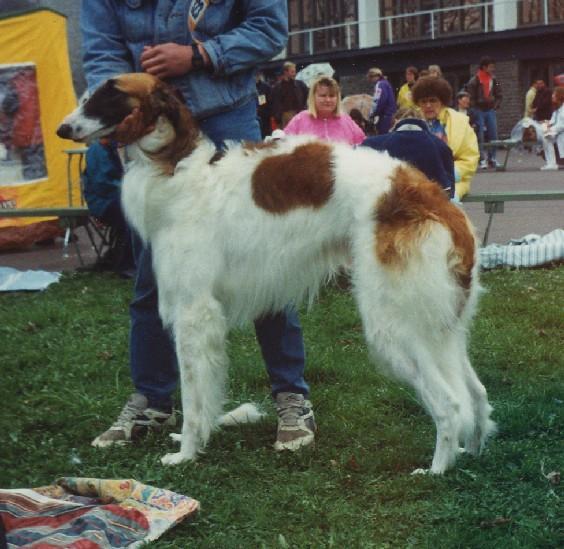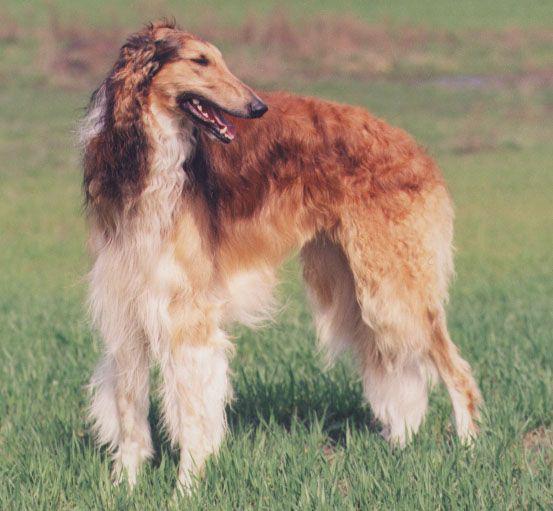The first image is the image on the left, the second image is the image on the right. Considering the images on both sides, is "All dogs are orange-and-white hounds standing with their bodies turned to the left, but one dog is looking back over its shoulder." valid? Answer yes or no. Yes. The first image is the image on the left, the second image is the image on the right. Assess this claim about the two images: "One dog's mouth is open and the other dog's mouth is closed.". Correct or not? Answer yes or no. Yes. 